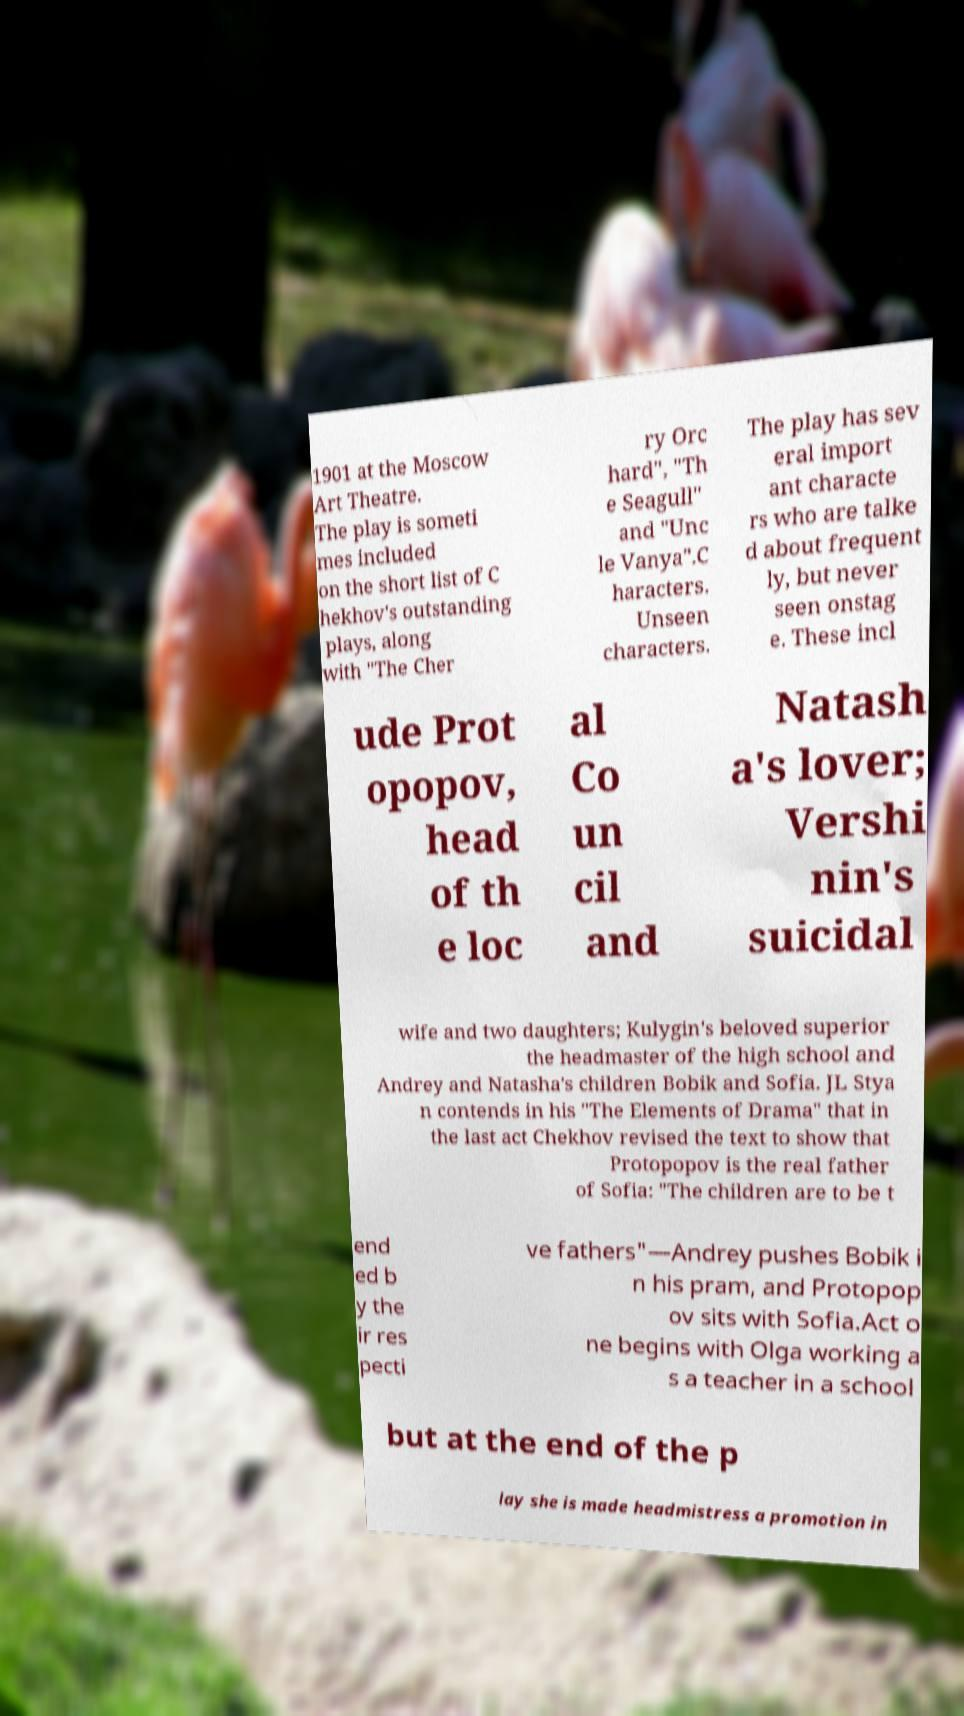Could you assist in decoding the text presented in this image and type it out clearly? 1901 at the Moscow Art Theatre. The play is someti mes included on the short list of C hekhov's outstanding plays, along with "The Cher ry Orc hard", "Th e Seagull" and "Unc le Vanya".C haracters. Unseen characters. The play has sev eral import ant characte rs who are talke d about frequent ly, but never seen onstag e. These incl ude Prot opopov, head of th e loc al Co un cil and Natash a's lover; Vershi nin's suicidal wife and two daughters; Kulygin's beloved superior the headmaster of the high school and Andrey and Natasha's children Bobik and Sofia. JL Stya n contends in his "The Elements of Drama" that in the last act Chekhov revised the text to show that Protopopov is the real father of Sofia: "The children are to be t end ed b y the ir res pecti ve fathers"—Andrey pushes Bobik i n his pram, and Protopop ov sits with Sofia.Act o ne begins with Olga working a s a teacher in a school but at the end of the p lay she is made headmistress a promotion in 